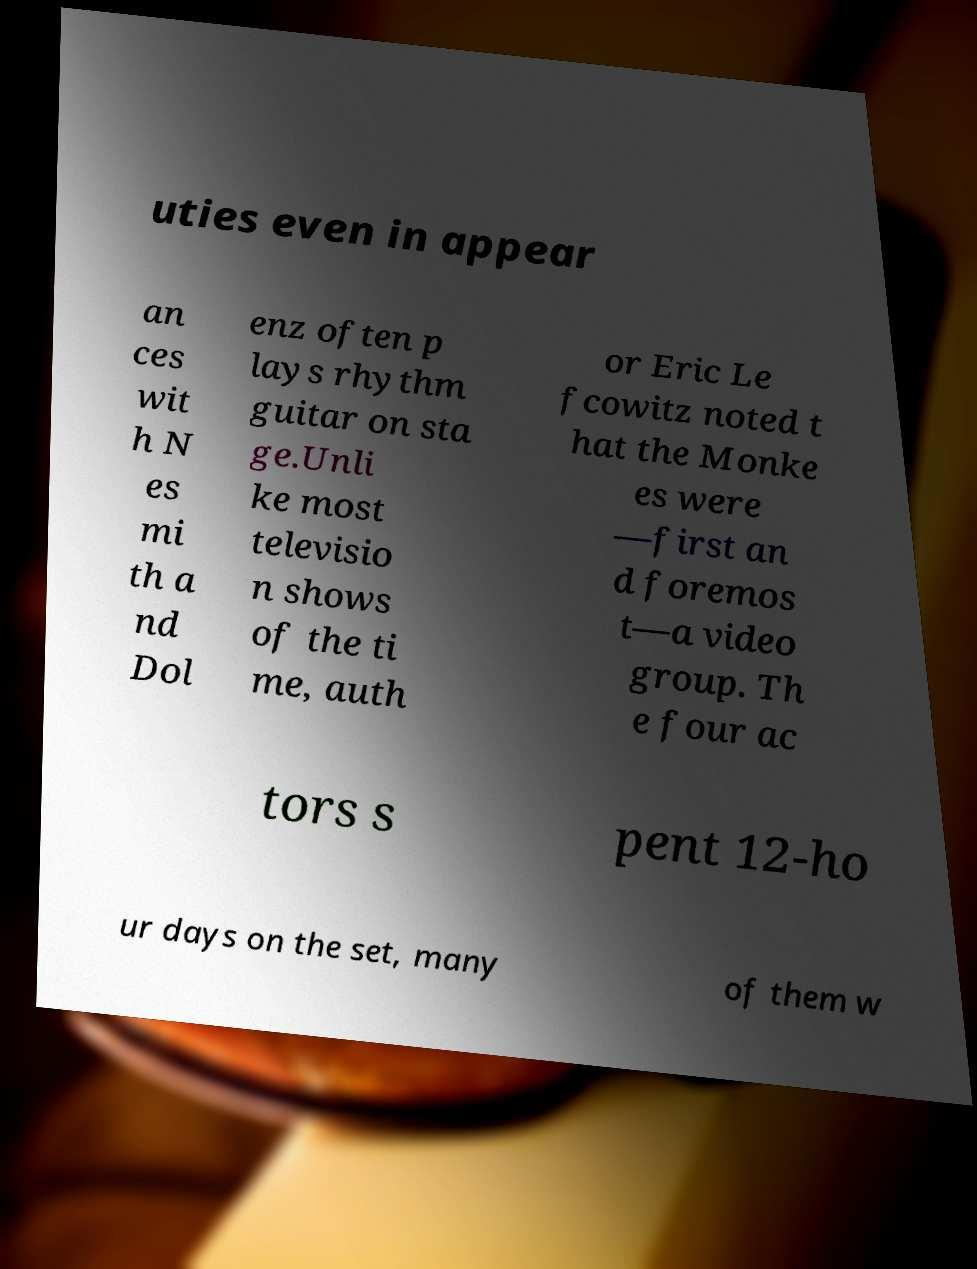Please identify and transcribe the text found in this image. uties even in appear an ces wit h N es mi th a nd Dol enz often p lays rhythm guitar on sta ge.Unli ke most televisio n shows of the ti me, auth or Eric Le fcowitz noted t hat the Monke es were —first an d foremos t—a video group. Th e four ac tors s pent 12-ho ur days on the set, many of them w 